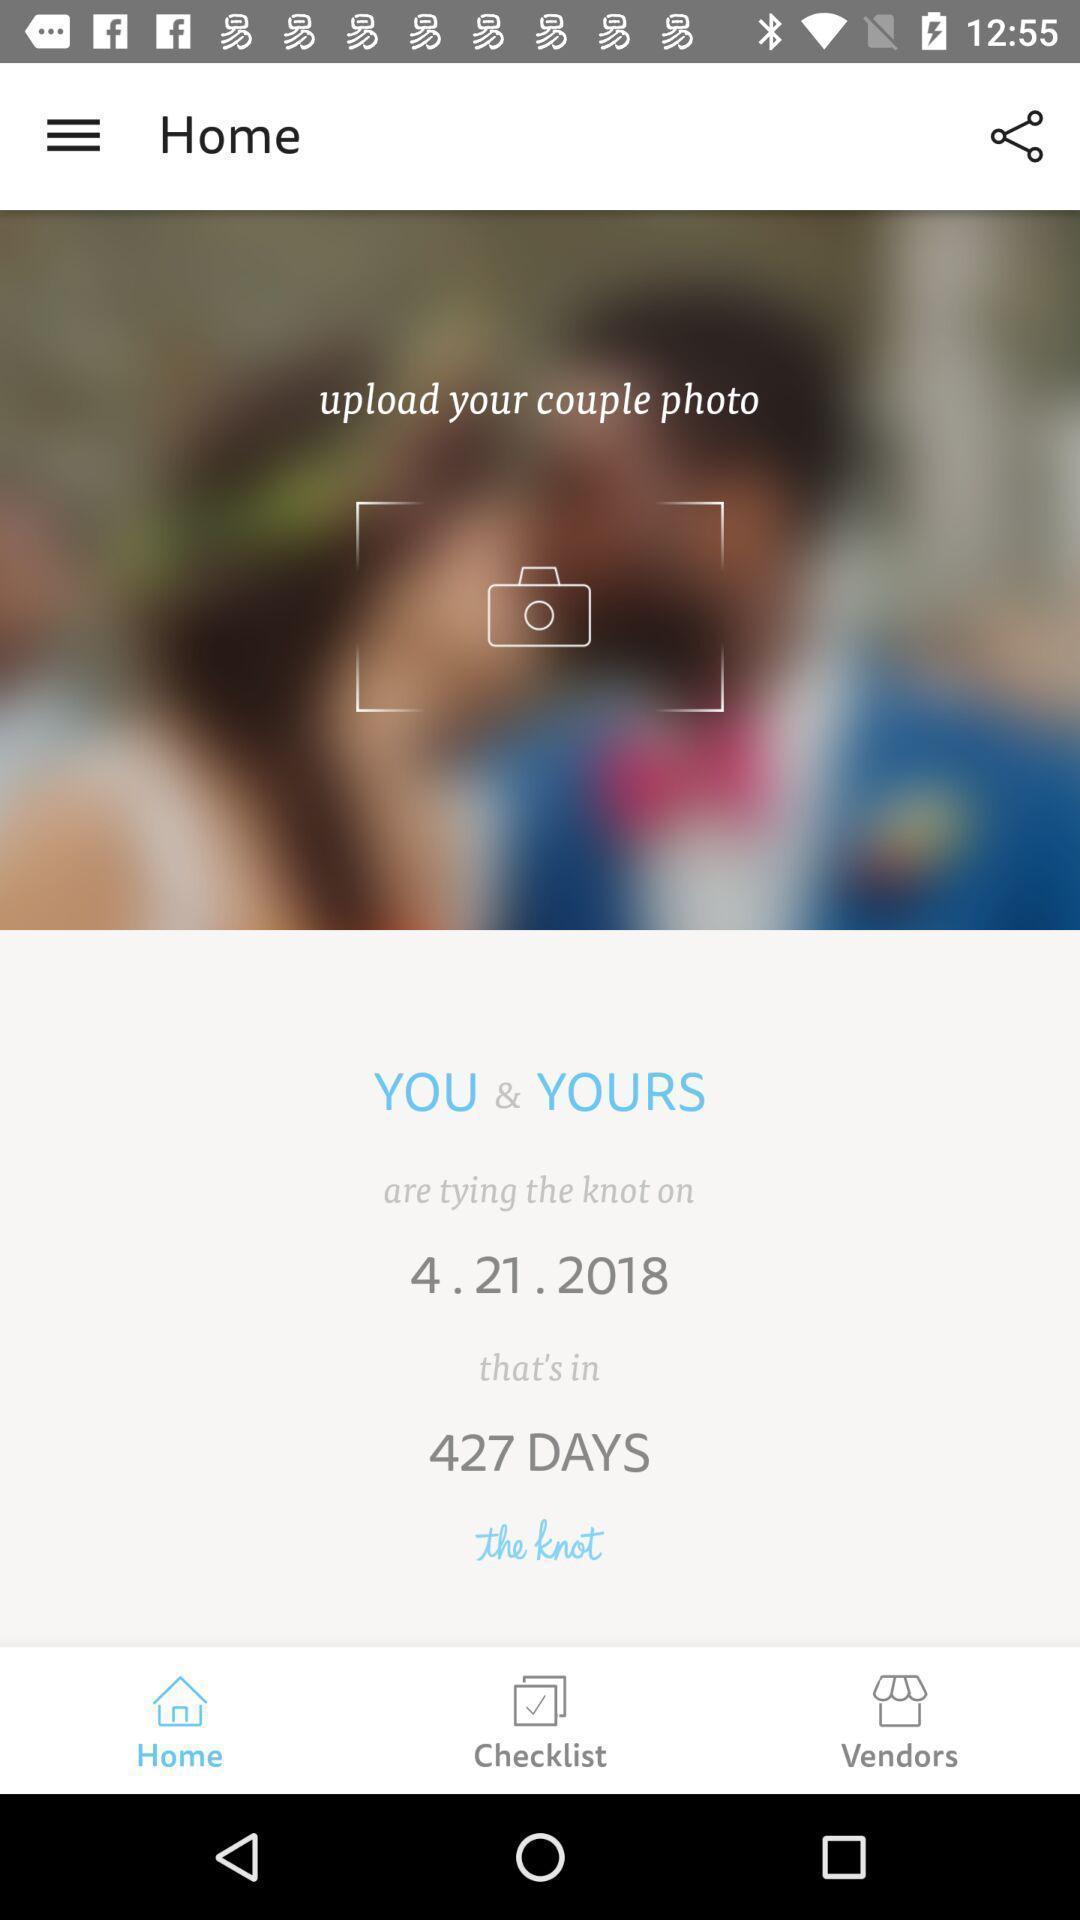What details can you identify in this image? Welcome to the home page. 